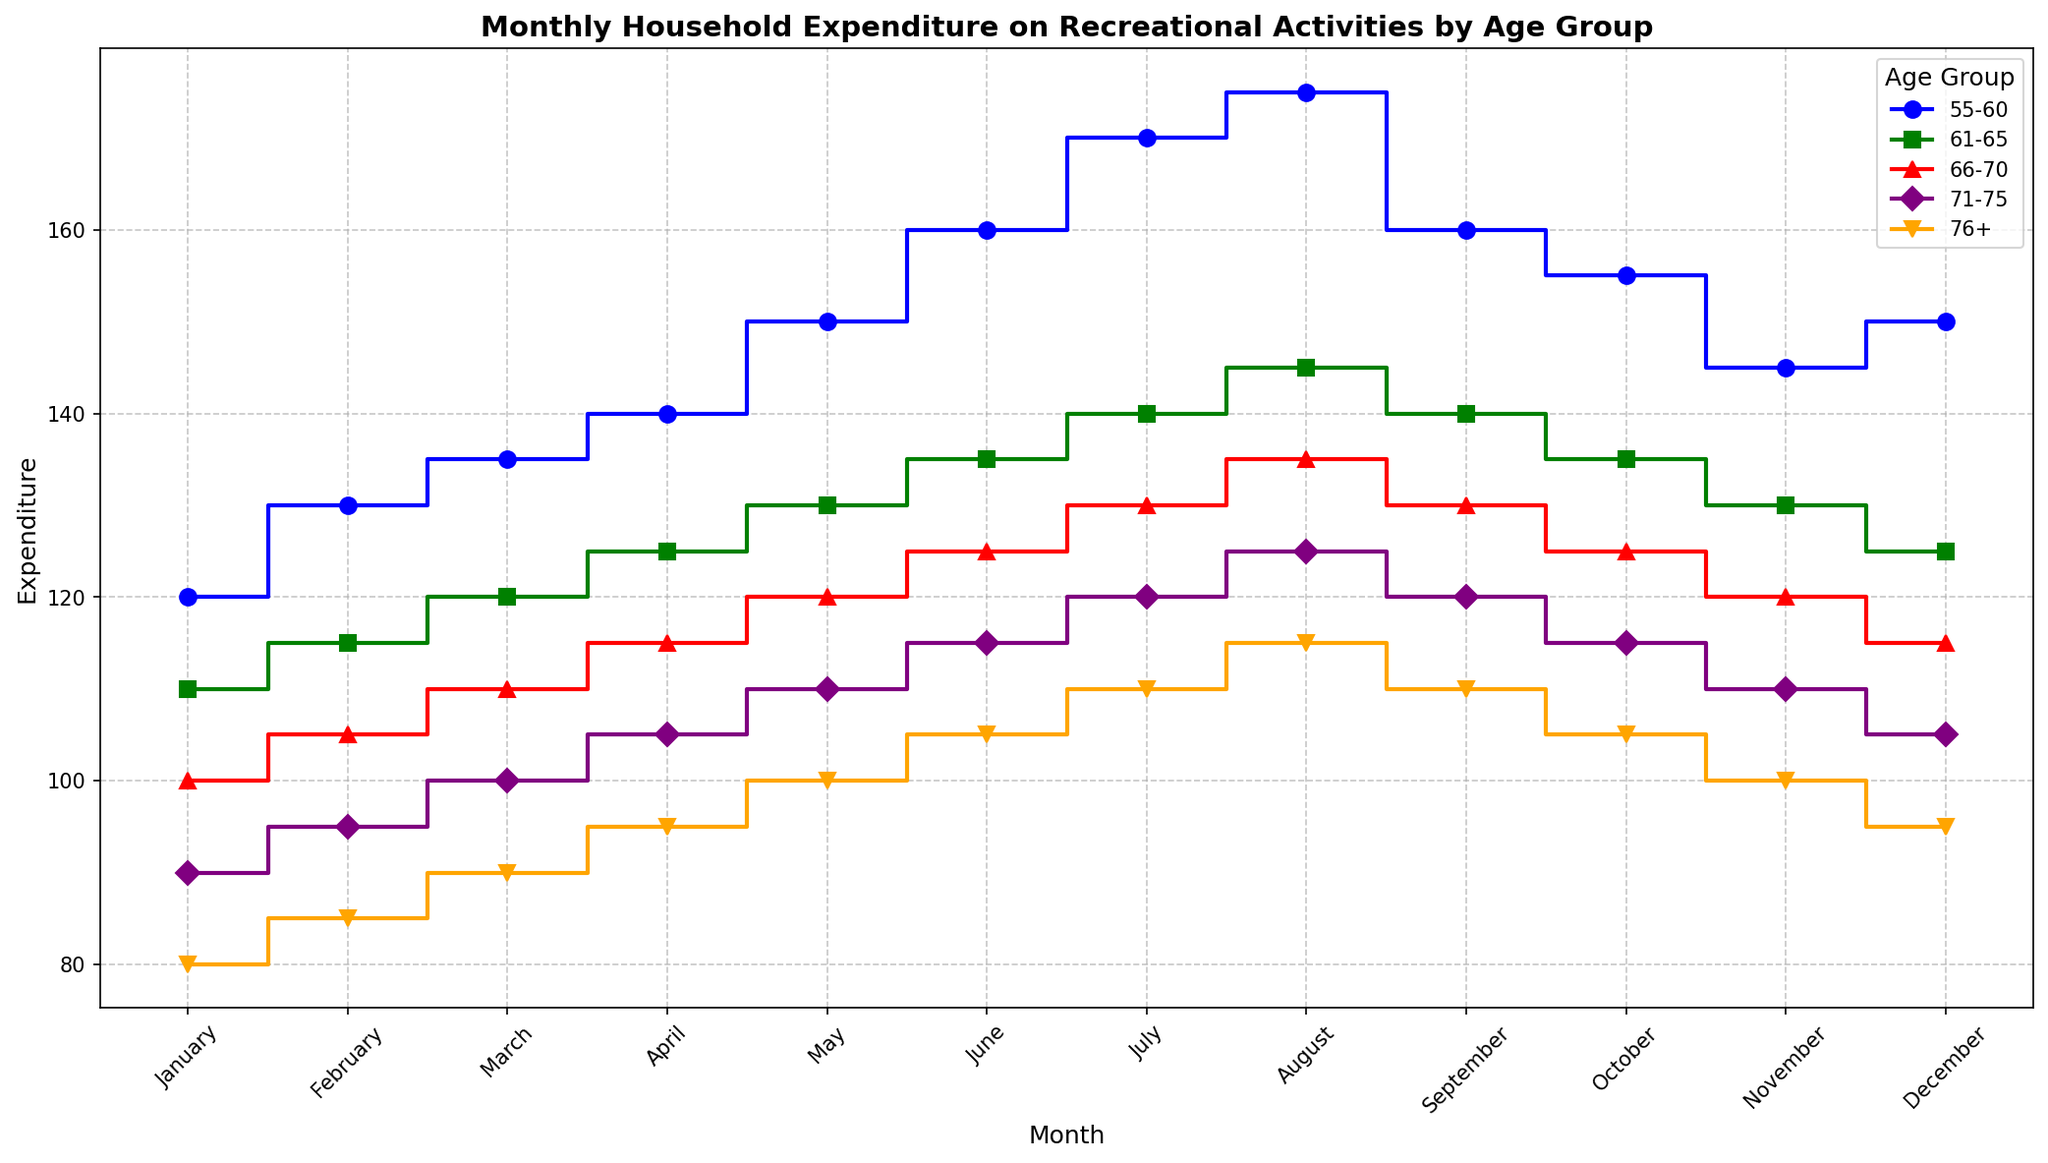Which age group had the highest expenditure in August? To find the age group with the highest expenditure in August, look at the plot where the different age groups are represented by different colors and markers. The highest value is for the 55-60 age group, marked with a blue "o".
Answer: 55-60 What is the total expenditure for the 66-70 age group in the first quarter (January to March)? Sum the expenditures for January, February, and March for the 66-70 age group (100 + 105 + 110).
Answer: 315 How does the expenditure for the 71-75 age group in December compare to November? Observe the height difference between the points marked for November and December for the 71-75 age group (orange "v"). The expenditure drops from 110 in November to 105 in December.
Answer: Decreases Which month shows the highest expenditure for the 55-60 age group? Look at the peak of the blue "o" markers, which represent the 55-60 age group. The highest point is in August with an expenditure of 175.
Answer: August What is the average monthly expenditure for the 61-65 age group? Sum the monthly expenditures for the 61-65 age group (110 + 115 + 120 + 125 + 130 + 135 + 140 + 145 + 140 + 135 + 130 + 125) and divide by 12 months. The sum is 1550, and the average is 1550/12.
Answer: 129.17 Compare the expenditures in July for the 55-60 and 76+ age groups. Which is higher and by how much? Check the values for July for both age groups. The 55-60 age group spent 170, while the 76+ age group spent 110. The difference is 170 - 110.
Answer: 55-60 by 60 What is the trend in expenditure for the 76+ age group from January to December? Observe the plot line for the 76+ age group (purple "D"). The expenditure generally increases from January (80) to August (115) and then decreases to December (95).
Answer: Increases then decreases 